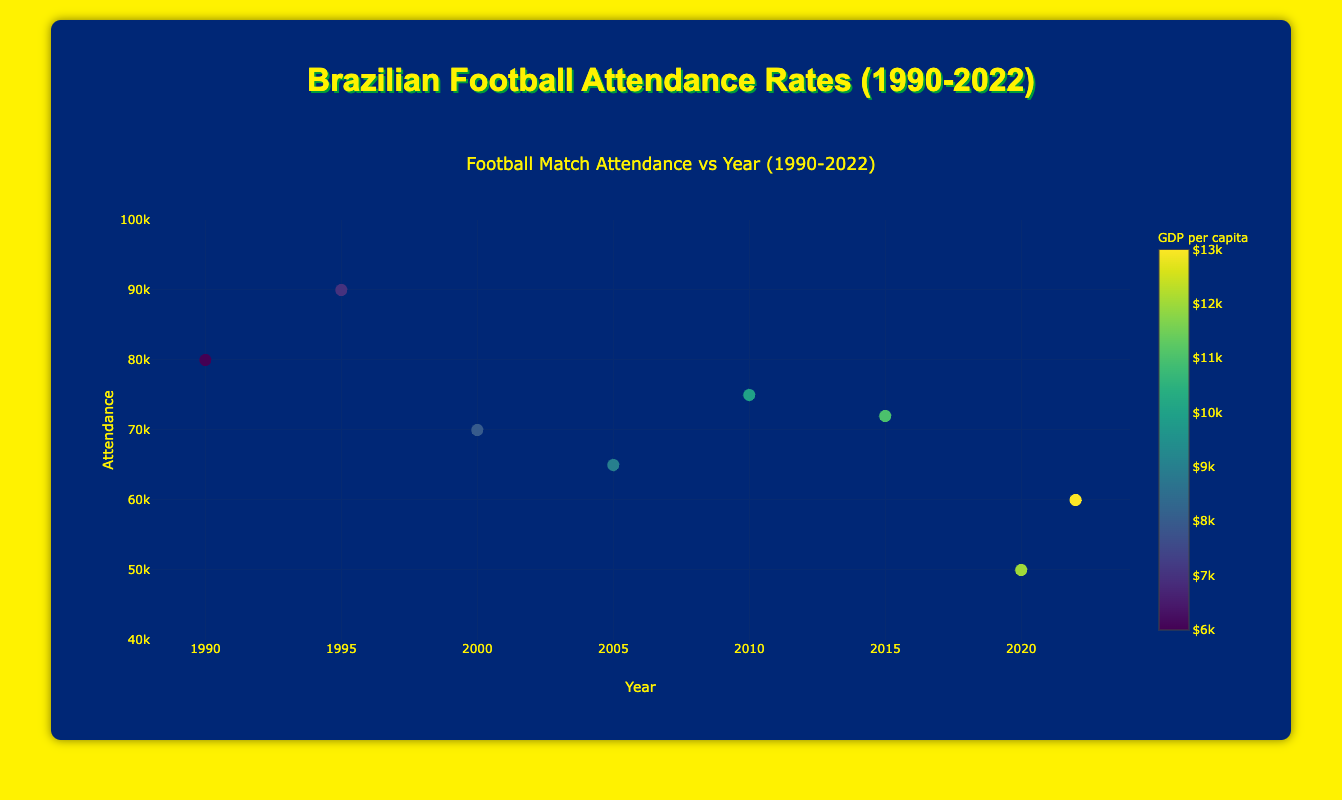What is the title of the figure? The title of the figure is displayed at the top and reads "Football Match Attendance vs Year (1990-2022)."
Answer: Football Match Attendance vs Year (1990-2022) How many data points are there in the figure? By counting the number of markers in the plot, it is evident there are 8 data points representing matches from 1990 to 2022.
Answer: 8 What is the GDP per capita for the match with the highest attendance? The highest attendance is 90,000 in 1995 for the match "Flamengo vs Vasco." The GDP per capita for that year is $7,000 as indicated by the color bar.
Answer: $7,000 How does the attendance trend with respect to the year look in the figure? By observing the scatter plot with the trend line, the attendance trend shows an overall decrease from 1990 to 2022.
Answer: Decreases Which match has the lowest attendance, and what year did it occur? The match "Palmeiras vs Corinthians" in 2020 has the lowest attendance of 50,000.
Answer: Palmeiras vs Corinthians, 2020 What is the unemployment rate for the match "São Paulo vs Santos"? By examining the hover information on the scatter plot for the year 2000, the unemployment rate is 6%.
Answer: 6% How does the average ticket price change over the years in the figure? By hovering over the different data points in the scatter plot and checking the respective years, it is seen that the average ticket price increases steadily from $10 in 1990 to $45 in 2022.
Answer: Increases Based on the scatter plot, what appears to be the correlation between GDP per capita and attendance? Observing the color gradient and the scatter points, there doesn't seem to be a strong direct correlation between GDP per capita and attendance, as high and low attendance both appear in various GDP per capita ranges.
Answer: Weak correlation Compare the attendance between the matches "Cruzeiro vs Atlético Mineiro" (2015) and "Fluminense vs Botafogo" (2010). Which had higher attendance? By examining the points for the years 2015 and 2010, "Fluminense vs Botafogo" in 2010 had an attendance of 75,000 compared to 72,000 for "Cruzeiro vs Atlético Mineiro" in 2015.
Answer: Fluminense vs Botafogo (2010) What is the general color scheme representing the GDP per capita in the figure, and which color represents the highest GDP per capita? The scatter plot uses a Viridis color scale, ranging from green to yellow. Yellow represents the highest GDP per capita.
Answer: Yellow 